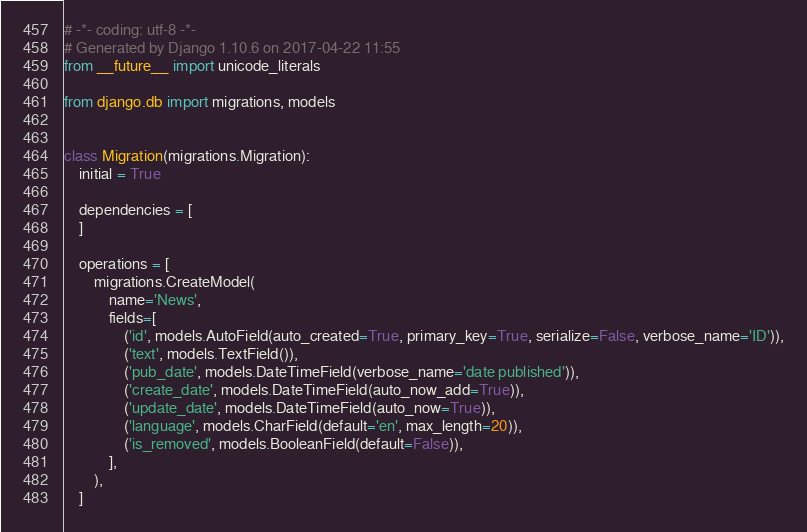Convert code to text. <code><loc_0><loc_0><loc_500><loc_500><_Python_># -*- coding: utf-8 -*-
# Generated by Django 1.10.6 on 2017-04-22 11:55
from __future__ import unicode_literals

from django.db import migrations, models


class Migration(migrations.Migration):
    initial = True

    dependencies = [
    ]

    operations = [
        migrations.CreateModel(
            name='News',
            fields=[
                ('id', models.AutoField(auto_created=True, primary_key=True, serialize=False, verbose_name='ID')),
                ('text', models.TextField()),
                ('pub_date', models.DateTimeField(verbose_name='date published')),
                ('create_date', models.DateTimeField(auto_now_add=True)),
                ('update_date', models.DateTimeField(auto_now=True)),
                ('language', models.CharField(default='en', max_length=20)),
                ('is_removed', models.BooleanField(default=False)),
            ],
        ),
    ]
</code> 